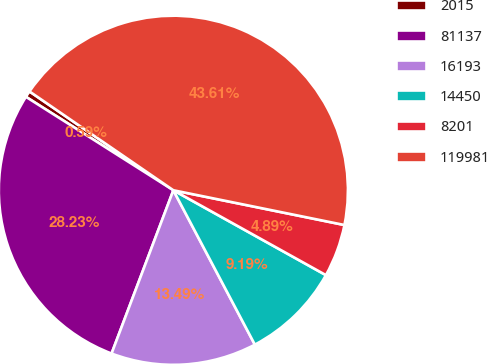Convert chart. <chart><loc_0><loc_0><loc_500><loc_500><pie_chart><fcel>2015<fcel>81137<fcel>16193<fcel>14450<fcel>8201<fcel>119981<nl><fcel>0.59%<fcel>28.23%<fcel>13.49%<fcel>9.19%<fcel>4.89%<fcel>43.61%<nl></chart> 